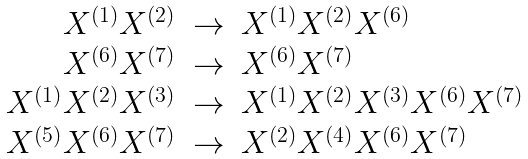Convert formula to latex. <formula><loc_0><loc_0><loc_500><loc_500>\begin{array} { r c l } X ^ { ( 1 ) } X ^ { ( 2 ) } & \rightarrow & X ^ { ( 1 ) } X ^ { ( 2 ) } X ^ { ( 6 ) } \\ X ^ { ( 6 ) } X ^ { ( 7 ) } & \rightarrow & X ^ { ( 6 ) } X ^ { ( 7 ) } \\ X ^ { ( 1 ) } X ^ { ( 2 ) } X ^ { ( 3 ) } & \rightarrow & X ^ { ( 1 ) } X ^ { ( 2 ) } X ^ { ( 3 ) } X ^ { ( 6 ) } X ^ { ( 7 ) } \\ X ^ { ( 5 ) } X ^ { ( 6 ) } X ^ { ( 7 ) } & \rightarrow & X ^ { ( 2 ) } X ^ { ( 4 ) } X ^ { ( 6 ) } X ^ { ( 7 ) } \, \end{array}</formula> 